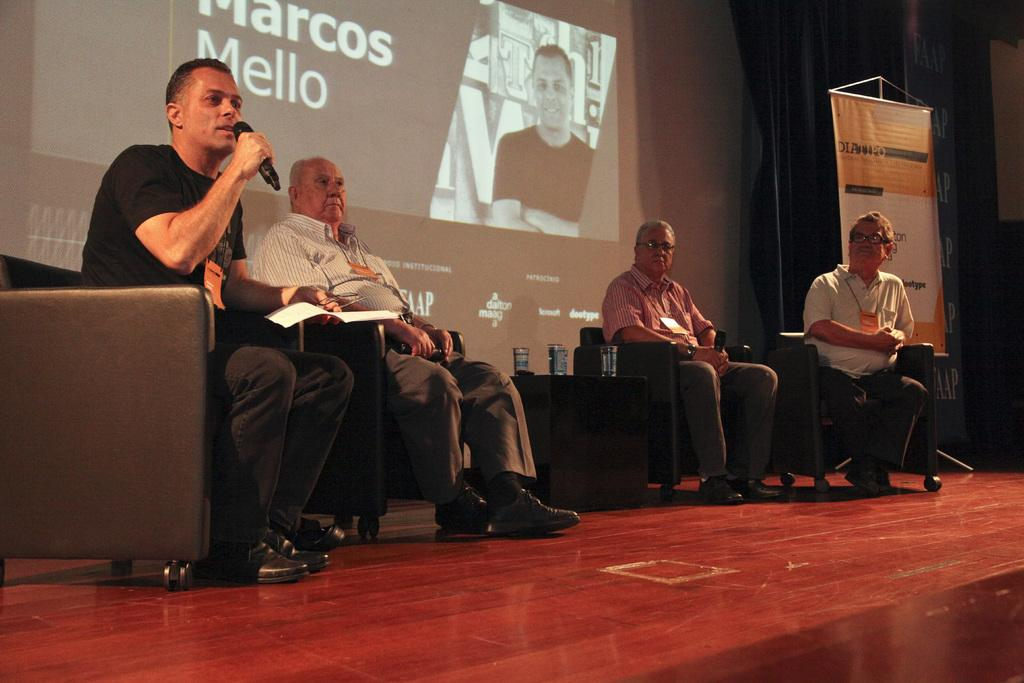What are the people in the image doing? The people in the image are sitting on chairs. What can be seen in the background of the image? There is a screen in the background of the image. What object is being held by one of the people? One person is holding a microphone in the image. Where is the stage located in the image? There is a stage at the bottom of the image. What type of haircut does the dad have in the image? There is no dad present in the image, and therefore no haircut to describe. What is the fork being used for in the image? There is no fork present in the image. 